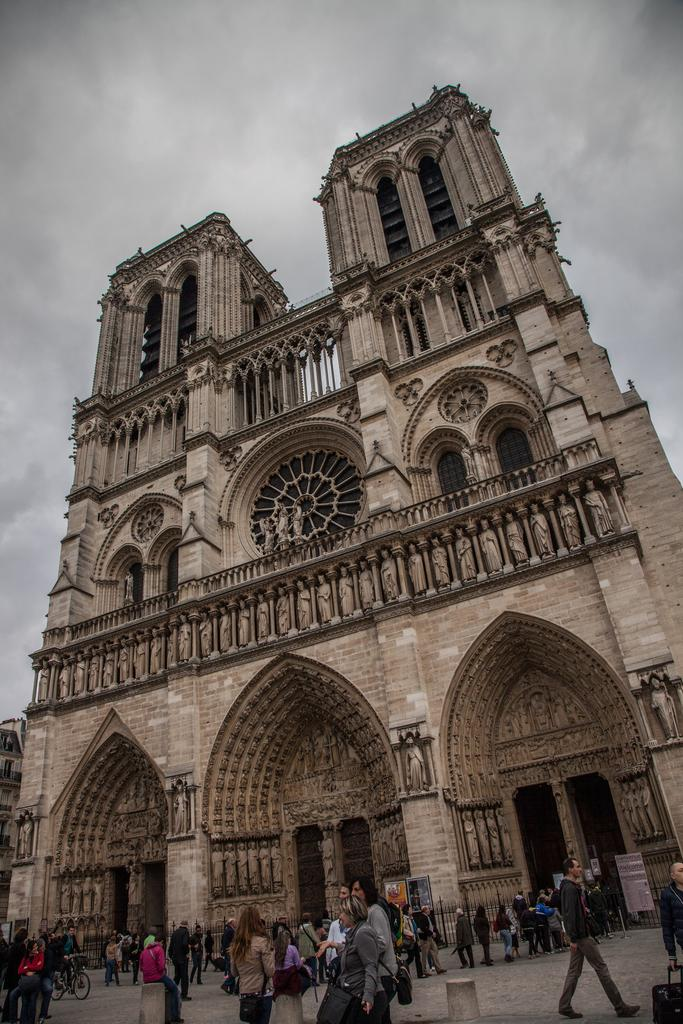What is the main subject in the center of the image? There is a building in the center of the image. What can be seen at the bottom of the image? There are persons at the bottom of the image. What type of natural elements can be seen in the background of the image? There are clouds in the background of the image. What else is visible in the background of the image? The sky is visible in the background of the image. What type of art is displayed on the boat in the image? There is no boat present in the image, so it is not possible to answer that question. 